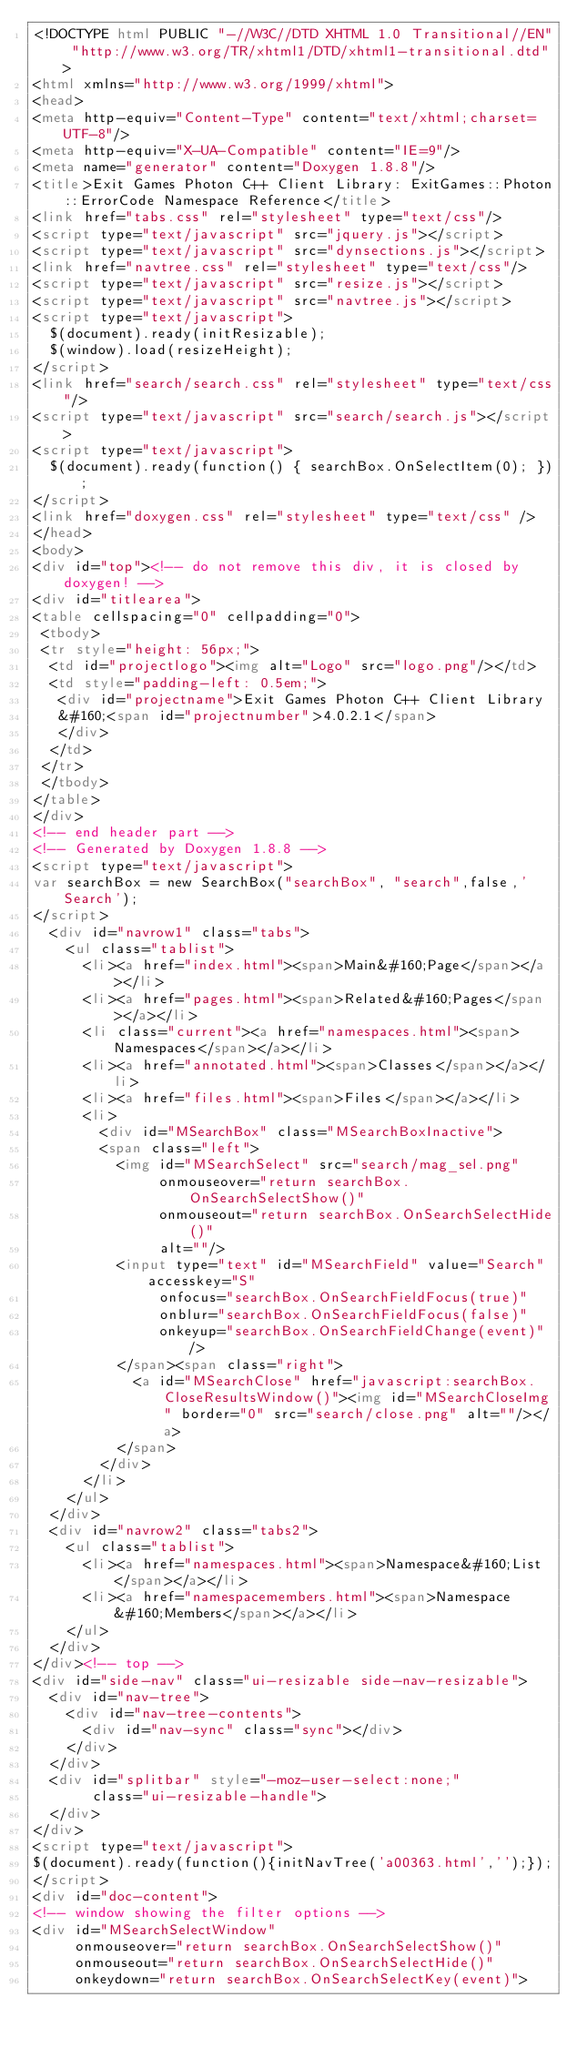<code> <loc_0><loc_0><loc_500><loc_500><_HTML_><!DOCTYPE html PUBLIC "-//W3C//DTD XHTML 1.0 Transitional//EN" "http://www.w3.org/TR/xhtml1/DTD/xhtml1-transitional.dtd">
<html xmlns="http://www.w3.org/1999/xhtml">
<head>
<meta http-equiv="Content-Type" content="text/xhtml;charset=UTF-8"/>
<meta http-equiv="X-UA-Compatible" content="IE=9"/>
<meta name="generator" content="Doxygen 1.8.8"/>
<title>Exit Games Photon C++ Client Library: ExitGames::Photon::ErrorCode Namespace Reference</title>
<link href="tabs.css" rel="stylesheet" type="text/css"/>
<script type="text/javascript" src="jquery.js"></script>
<script type="text/javascript" src="dynsections.js"></script>
<link href="navtree.css" rel="stylesheet" type="text/css"/>
<script type="text/javascript" src="resize.js"></script>
<script type="text/javascript" src="navtree.js"></script>
<script type="text/javascript">
  $(document).ready(initResizable);
  $(window).load(resizeHeight);
</script>
<link href="search/search.css" rel="stylesheet" type="text/css"/>
<script type="text/javascript" src="search/search.js"></script>
<script type="text/javascript">
  $(document).ready(function() { searchBox.OnSelectItem(0); });
</script>
<link href="doxygen.css" rel="stylesheet" type="text/css" />
</head>
<body>
<div id="top"><!-- do not remove this div, it is closed by doxygen! -->
<div id="titlearea">
<table cellspacing="0" cellpadding="0">
 <tbody>
 <tr style="height: 56px;">
  <td id="projectlogo"><img alt="Logo" src="logo.png"/></td>
  <td style="padding-left: 0.5em;">
   <div id="projectname">Exit Games Photon C++ Client Library
   &#160;<span id="projectnumber">4.0.2.1</span>
   </div>
  </td>
 </tr>
 </tbody>
</table>
</div>
<!-- end header part -->
<!-- Generated by Doxygen 1.8.8 -->
<script type="text/javascript">
var searchBox = new SearchBox("searchBox", "search",false,'Search');
</script>
  <div id="navrow1" class="tabs">
    <ul class="tablist">
      <li><a href="index.html"><span>Main&#160;Page</span></a></li>
      <li><a href="pages.html"><span>Related&#160;Pages</span></a></li>
      <li class="current"><a href="namespaces.html"><span>Namespaces</span></a></li>
      <li><a href="annotated.html"><span>Classes</span></a></li>
      <li><a href="files.html"><span>Files</span></a></li>
      <li>
        <div id="MSearchBox" class="MSearchBoxInactive">
        <span class="left">
          <img id="MSearchSelect" src="search/mag_sel.png"
               onmouseover="return searchBox.OnSearchSelectShow()"
               onmouseout="return searchBox.OnSearchSelectHide()"
               alt=""/>
          <input type="text" id="MSearchField" value="Search" accesskey="S"
               onfocus="searchBox.OnSearchFieldFocus(true)" 
               onblur="searchBox.OnSearchFieldFocus(false)" 
               onkeyup="searchBox.OnSearchFieldChange(event)"/>
          </span><span class="right">
            <a id="MSearchClose" href="javascript:searchBox.CloseResultsWindow()"><img id="MSearchCloseImg" border="0" src="search/close.png" alt=""/></a>
          </span>
        </div>
      </li>
    </ul>
  </div>
  <div id="navrow2" class="tabs2">
    <ul class="tablist">
      <li><a href="namespaces.html"><span>Namespace&#160;List</span></a></li>
      <li><a href="namespacemembers.html"><span>Namespace&#160;Members</span></a></li>
    </ul>
  </div>
</div><!-- top -->
<div id="side-nav" class="ui-resizable side-nav-resizable">
  <div id="nav-tree">
    <div id="nav-tree-contents">
      <div id="nav-sync" class="sync"></div>
    </div>
  </div>
  <div id="splitbar" style="-moz-user-select:none;" 
       class="ui-resizable-handle">
  </div>
</div>
<script type="text/javascript">
$(document).ready(function(){initNavTree('a00363.html','');});
</script>
<div id="doc-content">
<!-- window showing the filter options -->
<div id="MSearchSelectWindow"
     onmouseover="return searchBox.OnSearchSelectShow()"
     onmouseout="return searchBox.OnSearchSelectHide()"
     onkeydown="return searchBox.OnSearchSelectKey(event)"></code> 